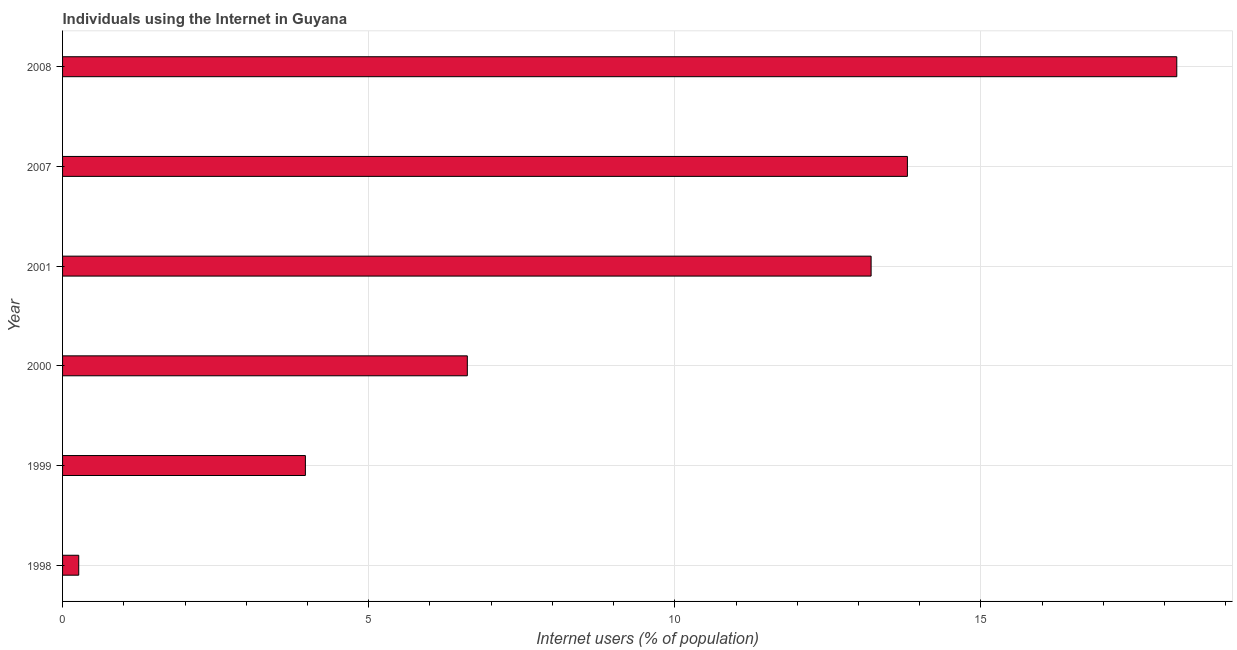What is the title of the graph?
Your response must be concise. Individuals using the Internet in Guyana. What is the label or title of the X-axis?
Your answer should be compact. Internet users (% of population). What is the number of internet users in 2001?
Ensure brevity in your answer.  13.21. Across all years, what is the minimum number of internet users?
Keep it short and to the point. 0.26. In which year was the number of internet users maximum?
Make the answer very short. 2008. What is the sum of the number of internet users?
Ensure brevity in your answer.  56.05. What is the difference between the number of internet users in 2007 and 2008?
Your answer should be very brief. -4.4. What is the average number of internet users per year?
Your answer should be compact. 9.34. What is the median number of internet users?
Make the answer very short. 9.91. In how many years, is the number of internet users greater than 11 %?
Offer a very short reply. 3. What is the difference between the highest and the second highest number of internet users?
Give a very brief answer. 4.4. Is the sum of the number of internet users in 2001 and 2008 greater than the maximum number of internet users across all years?
Provide a short and direct response. Yes. What is the difference between the highest and the lowest number of internet users?
Your answer should be very brief. 17.94. In how many years, is the number of internet users greater than the average number of internet users taken over all years?
Your response must be concise. 3. How many years are there in the graph?
Your response must be concise. 6. What is the Internet users (% of population) of 1998?
Ensure brevity in your answer.  0.26. What is the Internet users (% of population) in 1999?
Your answer should be very brief. 3.97. What is the Internet users (% of population) in 2000?
Your response must be concise. 6.61. What is the Internet users (% of population) of 2001?
Offer a terse response. 13.21. What is the difference between the Internet users (% of population) in 1998 and 1999?
Offer a terse response. -3.7. What is the difference between the Internet users (% of population) in 1998 and 2000?
Make the answer very short. -6.35. What is the difference between the Internet users (% of population) in 1998 and 2001?
Make the answer very short. -12.94. What is the difference between the Internet users (% of population) in 1998 and 2007?
Give a very brief answer. -13.54. What is the difference between the Internet users (% of population) in 1998 and 2008?
Your answer should be compact. -17.94. What is the difference between the Internet users (% of population) in 1999 and 2000?
Your answer should be very brief. -2.65. What is the difference between the Internet users (% of population) in 1999 and 2001?
Your answer should be compact. -9.24. What is the difference between the Internet users (% of population) in 1999 and 2007?
Your answer should be very brief. -9.83. What is the difference between the Internet users (% of population) in 1999 and 2008?
Offer a terse response. -14.23. What is the difference between the Internet users (% of population) in 2000 and 2001?
Provide a succinct answer. -6.6. What is the difference between the Internet users (% of population) in 2000 and 2007?
Give a very brief answer. -7.19. What is the difference between the Internet users (% of population) in 2000 and 2008?
Provide a succinct answer. -11.59. What is the difference between the Internet users (% of population) in 2001 and 2007?
Offer a very short reply. -0.59. What is the difference between the Internet users (% of population) in 2001 and 2008?
Your answer should be very brief. -4.99. What is the ratio of the Internet users (% of population) in 1998 to that in 1999?
Your answer should be compact. 0.07. What is the ratio of the Internet users (% of population) in 1998 to that in 2000?
Provide a succinct answer. 0.04. What is the ratio of the Internet users (% of population) in 1998 to that in 2001?
Ensure brevity in your answer.  0.02. What is the ratio of the Internet users (% of population) in 1998 to that in 2007?
Provide a short and direct response. 0.02. What is the ratio of the Internet users (% of population) in 1998 to that in 2008?
Your answer should be compact. 0.01. What is the ratio of the Internet users (% of population) in 1999 to that in 2000?
Keep it short and to the point. 0.6. What is the ratio of the Internet users (% of population) in 1999 to that in 2001?
Keep it short and to the point. 0.3. What is the ratio of the Internet users (% of population) in 1999 to that in 2007?
Keep it short and to the point. 0.29. What is the ratio of the Internet users (% of population) in 1999 to that in 2008?
Provide a succinct answer. 0.22. What is the ratio of the Internet users (% of population) in 2000 to that in 2001?
Your answer should be very brief. 0.5. What is the ratio of the Internet users (% of population) in 2000 to that in 2007?
Offer a very short reply. 0.48. What is the ratio of the Internet users (% of population) in 2000 to that in 2008?
Your answer should be very brief. 0.36. What is the ratio of the Internet users (% of population) in 2001 to that in 2008?
Offer a very short reply. 0.73. What is the ratio of the Internet users (% of population) in 2007 to that in 2008?
Provide a short and direct response. 0.76. 